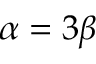<formula> <loc_0><loc_0><loc_500><loc_500>\alpha = 3 \beta</formula> 